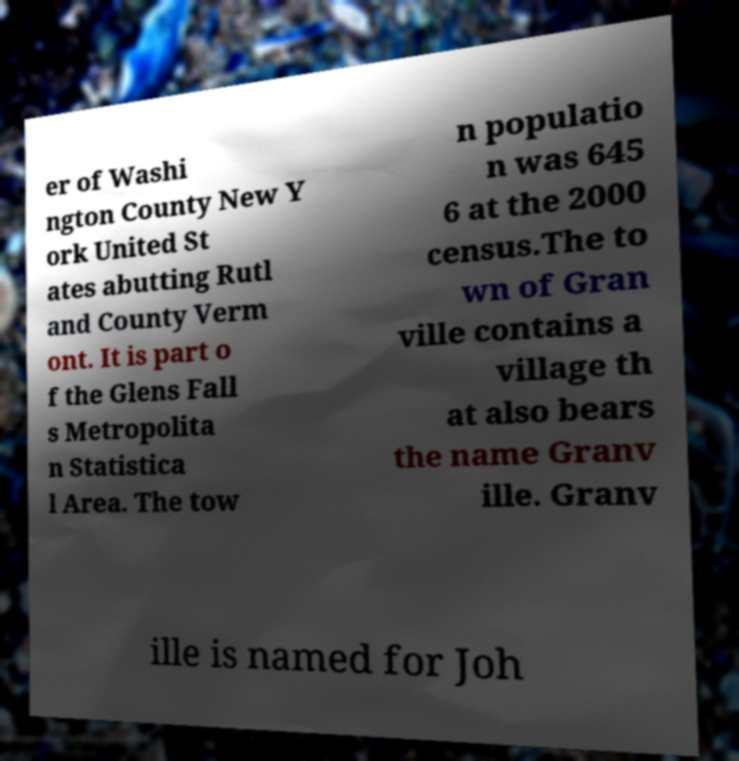Please identify and transcribe the text found in this image. er of Washi ngton County New Y ork United St ates abutting Rutl and County Verm ont. It is part o f the Glens Fall s Metropolita n Statistica l Area. The tow n populatio n was 645 6 at the 2000 census.The to wn of Gran ville contains a village th at also bears the name Granv ille. Granv ille is named for Joh 